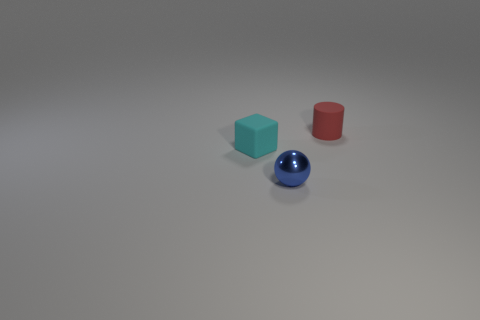Does the ball have the same material as the thing to the left of the small metal object?
Keep it short and to the point. No. Is the number of tiny spheres that are to the right of the tiny blue metal object less than the number of small metal objects that are on the right side of the small cyan thing?
Give a very brief answer. Yes. What is the color of the tiny rubber object in front of the matte cylinder?
Offer a very short reply. Cyan. There is a thing in front of the cyan rubber object; is its size the same as the small cyan object?
Provide a succinct answer. Yes. There is a small block; what number of tiny red cylinders are in front of it?
Offer a very short reply. 0. Is there a blue thing of the same size as the red rubber cylinder?
Your answer should be very brief. Yes. What is the color of the small object that is behind the small thing that is on the left side of the metallic sphere?
Make the answer very short. Red. What number of tiny objects are in front of the tiny red object and behind the small blue sphere?
Keep it short and to the point. 1. What number of other blue metal things are the same shape as the metallic thing?
Give a very brief answer. 0. Do the cylinder and the blue thing have the same material?
Make the answer very short. No. 